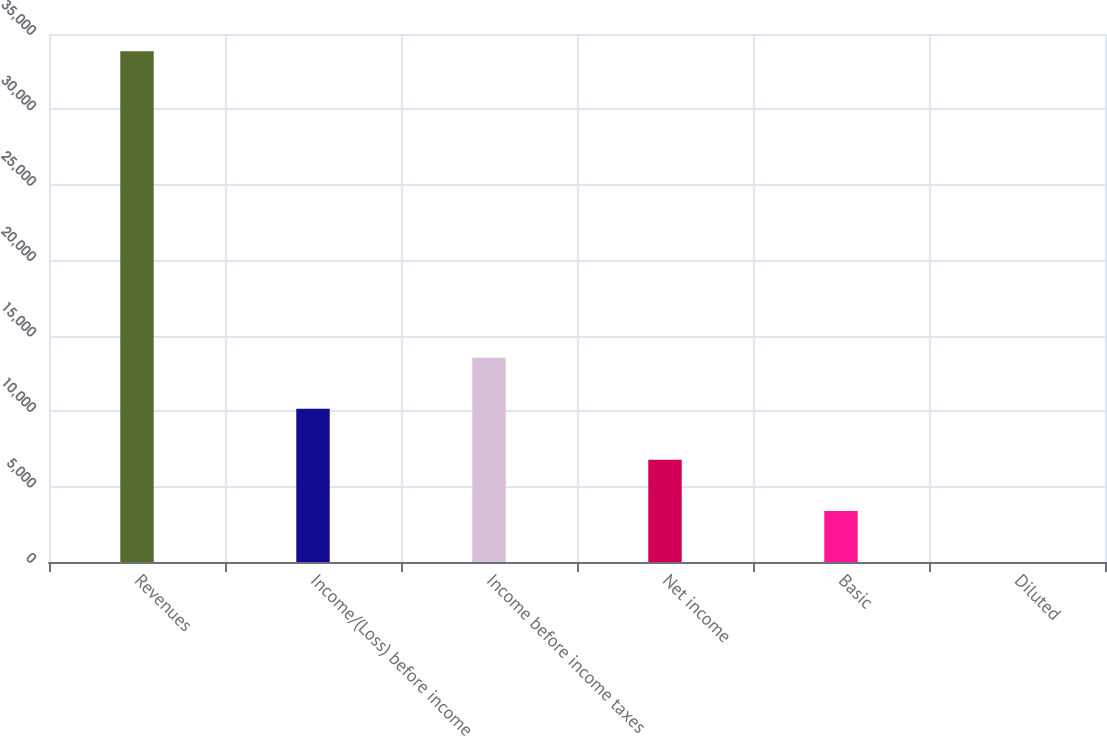Convert chart to OTSL. <chart><loc_0><loc_0><loc_500><loc_500><bar_chart><fcel>Revenues<fcel>Income/(Loss) before income<fcel>Income before income taxes<fcel>Net income<fcel>Basic<fcel>Diluted<nl><fcel>33857<fcel>10157.3<fcel>13543<fcel>6771.65<fcel>3385.98<fcel>0.31<nl></chart> 